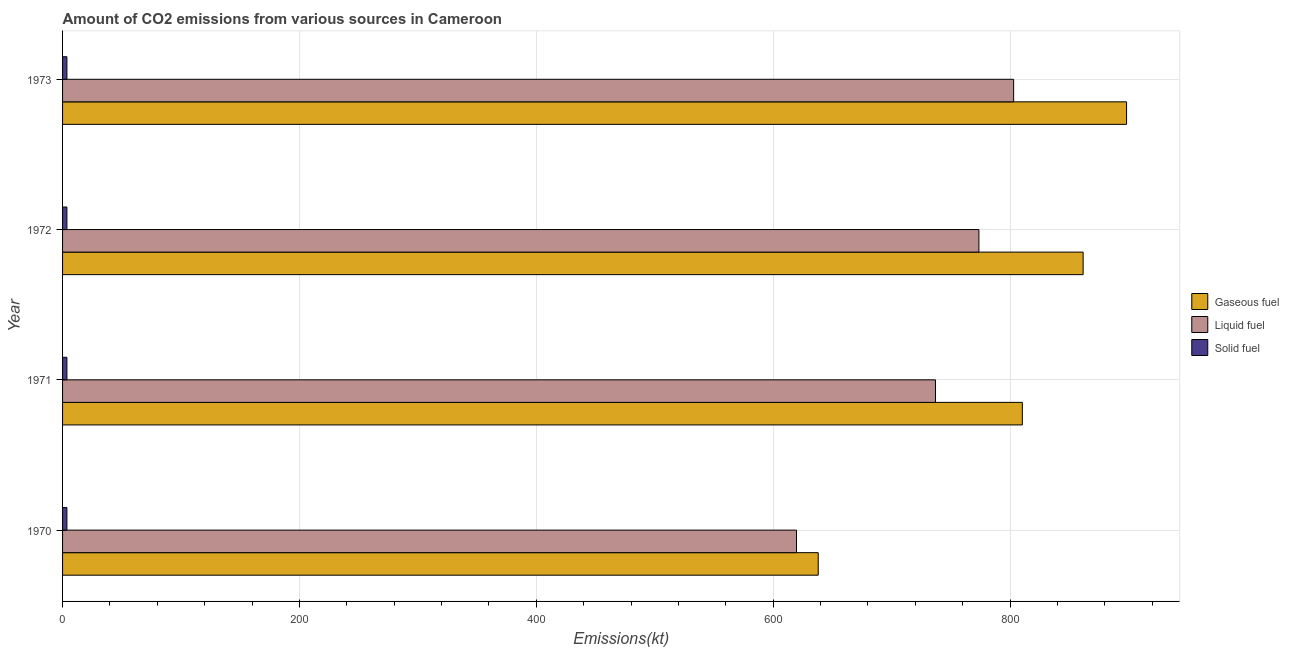How many groups of bars are there?
Give a very brief answer. 4. How many bars are there on the 1st tick from the top?
Your response must be concise. 3. What is the amount of co2 emissions from solid fuel in 1973?
Ensure brevity in your answer.  3.67. Across all years, what is the maximum amount of co2 emissions from gaseous fuel?
Give a very brief answer. 898.41. Across all years, what is the minimum amount of co2 emissions from liquid fuel?
Make the answer very short. 619.72. In which year was the amount of co2 emissions from gaseous fuel maximum?
Offer a terse response. 1973. What is the total amount of co2 emissions from gaseous fuel in the graph?
Make the answer very short. 3208.62. What is the difference between the amount of co2 emissions from gaseous fuel in 1970 and that in 1973?
Give a very brief answer. -260.36. What is the difference between the amount of co2 emissions from gaseous fuel in 1973 and the amount of co2 emissions from solid fuel in 1971?
Make the answer very short. 894.75. What is the average amount of co2 emissions from solid fuel per year?
Your answer should be very brief. 3.67. In the year 1972, what is the difference between the amount of co2 emissions from liquid fuel and amount of co2 emissions from gaseous fuel?
Offer a terse response. -88.01. In how many years, is the amount of co2 emissions from gaseous fuel greater than 120 kt?
Keep it short and to the point. 4. Is the amount of co2 emissions from liquid fuel in 1971 less than that in 1972?
Provide a short and direct response. Yes. What is the difference between the highest and the second highest amount of co2 emissions from gaseous fuel?
Your response must be concise. 36.67. What is the difference between the highest and the lowest amount of co2 emissions from solid fuel?
Offer a very short reply. 0. What does the 1st bar from the top in 1973 represents?
Provide a succinct answer. Solid fuel. What does the 3rd bar from the bottom in 1970 represents?
Keep it short and to the point. Solid fuel. How many bars are there?
Your answer should be very brief. 12. What is the difference between two consecutive major ticks on the X-axis?
Make the answer very short. 200. Does the graph contain grids?
Give a very brief answer. Yes. Where does the legend appear in the graph?
Your response must be concise. Center right. How are the legend labels stacked?
Provide a short and direct response. Vertical. What is the title of the graph?
Offer a very short reply. Amount of CO2 emissions from various sources in Cameroon. Does "Infant(female)" appear as one of the legend labels in the graph?
Keep it short and to the point. No. What is the label or title of the X-axis?
Your answer should be very brief. Emissions(kt). What is the Emissions(kt) of Gaseous fuel in 1970?
Make the answer very short. 638.06. What is the Emissions(kt) of Liquid fuel in 1970?
Keep it short and to the point. 619.72. What is the Emissions(kt) in Solid fuel in 1970?
Your answer should be very brief. 3.67. What is the Emissions(kt) of Gaseous fuel in 1971?
Keep it short and to the point. 810.41. What is the Emissions(kt) of Liquid fuel in 1971?
Your answer should be very brief. 737.07. What is the Emissions(kt) in Solid fuel in 1971?
Offer a very short reply. 3.67. What is the Emissions(kt) of Gaseous fuel in 1972?
Ensure brevity in your answer.  861.75. What is the Emissions(kt) of Liquid fuel in 1972?
Ensure brevity in your answer.  773.74. What is the Emissions(kt) in Solid fuel in 1972?
Ensure brevity in your answer.  3.67. What is the Emissions(kt) of Gaseous fuel in 1973?
Keep it short and to the point. 898.41. What is the Emissions(kt) of Liquid fuel in 1973?
Give a very brief answer. 803.07. What is the Emissions(kt) in Solid fuel in 1973?
Give a very brief answer. 3.67. Across all years, what is the maximum Emissions(kt) of Gaseous fuel?
Give a very brief answer. 898.41. Across all years, what is the maximum Emissions(kt) of Liquid fuel?
Make the answer very short. 803.07. Across all years, what is the maximum Emissions(kt) in Solid fuel?
Keep it short and to the point. 3.67. Across all years, what is the minimum Emissions(kt) in Gaseous fuel?
Your response must be concise. 638.06. Across all years, what is the minimum Emissions(kt) of Liquid fuel?
Offer a terse response. 619.72. Across all years, what is the minimum Emissions(kt) of Solid fuel?
Provide a short and direct response. 3.67. What is the total Emissions(kt) in Gaseous fuel in the graph?
Keep it short and to the point. 3208.62. What is the total Emissions(kt) in Liquid fuel in the graph?
Give a very brief answer. 2933.6. What is the total Emissions(kt) in Solid fuel in the graph?
Provide a short and direct response. 14.67. What is the difference between the Emissions(kt) of Gaseous fuel in 1970 and that in 1971?
Offer a very short reply. -172.35. What is the difference between the Emissions(kt) of Liquid fuel in 1970 and that in 1971?
Your answer should be very brief. -117.34. What is the difference between the Emissions(kt) in Gaseous fuel in 1970 and that in 1972?
Provide a succinct answer. -223.69. What is the difference between the Emissions(kt) in Liquid fuel in 1970 and that in 1972?
Make the answer very short. -154.01. What is the difference between the Emissions(kt) of Solid fuel in 1970 and that in 1972?
Keep it short and to the point. 0. What is the difference between the Emissions(kt) of Gaseous fuel in 1970 and that in 1973?
Offer a terse response. -260.36. What is the difference between the Emissions(kt) in Liquid fuel in 1970 and that in 1973?
Give a very brief answer. -183.35. What is the difference between the Emissions(kt) in Solid fuel in 1970 and that in 1973?
Provide a short and direct response. 0. What is the difference between the Emissions(kt) in Gaseous fuel in 1971 and that in 1972?
Your response must be concise. -51.34. What is the difference between the Emissions(kt) in Liquid fuel in 1971 and that in 1972?
Offer a very short reply. -36.67. What is the difference between the Emissions(kt) in Solid fuel in 1971 and that in 1972?
Your answer should be compact. 0. What is the difference between the Emissions(kt) in Gaseous fuel in 1971 and that in 1973?
Offer a very short reply. -88.01. What is the difference between the Emissions(kt) of Liquid fuel in 1971 and that in 1973?
Give a very brief answer. -66.01. What is the difference between the Emissions(kt) in Gaseous fuel in 1972 and that in 1973?
Make the answer very short. -36.67. What is the difference between the Emissions(kt) of Liquid fuel in 1972 and that in 1973?
Your response must be concise. -29.34. What is the difference between the Emissions(kt) in Gaseous fuel in 1970 and the Emissions(kt) in Liquid fuel in 1971?
Provide a short and direct response. -99.01. What is the difference between the Emissions(kt) in Gaseous fuel in 1970 and the Emissions(kt) in Solid fuel in 1971?
Provide a succinct answer. 634.39. What is the difference between the Emissions(kt) of Liquid fuel in 1970 and the Emissions(kt) of Solid fuel in 1971?
Offer a terse response. 616.06. What is the difference between the Emissions(kt) of Gaseous fuel in 1970 and the Emissions(kt) of Liquid fuel in 1972?
Give a very brief answer. -135.68. What is the difference between the Emissions(kt) in Gaseous fuel in 1970 and the Emissions(kt) in Solid fuel in 1972?
Provide a short and direct response. 634.39. What is the difference between the Emissions(kt) of Liquid fuel in 1970 and the Emissions(kt) of Solid fuel in 1972?
Provide a short and direct response. 616.06. What is the difference between the Emissions(kt) in Gaseous fuel in 1970 and the Emissions(kt) in Liquid fuel in 1973?
Your answer should be compact. -165.01. What is the difference between the Emissions(kt) of Gaseous fuel in 1970 and the Emissions(kt) of Solid fuel in 1973?
Your response must be concise. 634.39. What is the difference between the Emissions(kt) in Liquid fuel in 1970 and the Emissions(kt) in Solid fuel in 1973?
Offer a very short reply. 616.06. What is the difference between the Emissions(kt) of Gaseous fuel in 1971 and the Emissions(kt) of Liquid fuel in 1972?
Provide a succinct answer. 36.67. What is the difference between the Emissions(kt) of Gaseous fuel in 1971 and the Emissions(kt) of Solid fuel in 1972?
Provide a short and direct response. 806.74. What is the difference between the Emissions(kt) in Liquid fuel in 1971 and the Emissions(kt) in Solid fuel in 1972?
Ensure brevity in your answer.  733.4. What is the difference between the Emissions(kt) in Gaseous fuel in 1971 and the Emissions(kt) in Liquid fuel in 1973?
Your answer should be compact. 7.33. What is the difference between the Emissions(kt) of Gaseous fuel in 1971 and the Emissions(kt) of Solid fuel in 1973?
Ensure brevity in your answer.  806.74. What is the difference between the Emissions(kt) of Liquid fuel in 1971 and the Emissions(kt) of Solid fuel in 1973?
Provide a succinct answer. 733.4. What is the difference between the Emissions(kt) of Gaseous fuel in 1972 and the Emissions(kt) of Liquid fuel in 1973?
Your answer should be compact. 58.67. What is the difference between the Emissions(kt) of Gaseous fuel in 1972 and the Emissions(kt) of Solid fuel in 1973?
Your answer should be compact. 858.08. What is the difference between the Emissions(kt) of Liquid fuel in 1972 and the Emissions(kt) of Solid fuel in 1973?
Keep it short and to the point. 770.07. What is the average Emissions(kt) of Gaseous fuel per year?
Provide a succinct answer. 802.16. What is the average Emissions(kt) in Liquid fuel per year?
Provide a succinct answer. 733.4. What is the average Emissions(kt) in Solid fuel per year?
Offer a terse response. 3.67. In the year 1970, what is the difference between the Emissions(kt) in Gaseous fuel and Emissions(kt) in Liquid fuel?
Make the answer very short. 18.34. In the year 1970, what is the difference between the Emissions(kt) of Gaseous fuel and Emissions(kt) of Solid fuel?
Offer a terse response. 634.39. In the year 1970, what is the difference between the Emissions(kt) in Liquid fuel and Emissions(kt) in Solid fuel?
Provide a succinct answer. 616.06. In the year 1971, what is the difference between the Emissions(kt) of Gaseous fuel and Emissions(kt) of Liquid fuel?
Your answer should be very brief. 73.34. In the year 1971, what is the difference between the Emissions(kt) of Gaseous fuel and Emissions(kt) of Solid fuel?
Your answer should be very brief. 806.74. In the year 1971, what is the difference between the Emissions(kt) in Liquid fuel and Emissions(kt) in Solid fuel?
Keep it short and to the point. 733.4. In the year 1972, what is the difference between the Emissions(kt) of Gaseous fuel and Emissions(kt) of Liquid fuel?
Ensure brevity in your answer.  88.01. In the year 1972, what is the difference between the Emissions(kt) in Gaseous fuel and Emissions(kt) in Solid fuel?
Your answer should be compact. 858.08. In the year 1972, what is the difference between the Emissions(kt) in Liquid fuel and Emissions(kt) in Solid fuel?
Provide a succinct answer. 770.07. In the year 1973, what is the difference between the Emissions(kt) in Gaseous fuel and Emissions(kt) in Liquid fuel?
Your answer should be compact. 95.34. In the year 1973, what is the difference between the Emissions(kt) of Gaseous fuel and Emissions(kt) of Solid fuel?
Ensure brevity in your answer.  894.75. In the year 1973, what is the difference between the Emissions(kt) in Liquid fuel and Emissions(kt) in Solid fuel?
Give a very brief answer. 799.41. What is the ratio of the Emissions(kt) of Gaseous fuel in 1970 to that in 1971?
Provide a short and direct response. 0.79. What is the ratio of the Emissions(kt) in Liquid fuel in 1970 to that in 1971?
Ensure brevity in your answer.  0.84. What is the ratio of the Emissions(kt) of Gaseous fuel in 1970 to that in 1972?
Your response must be concise. 0.74. What is the ratio of the Emissions(kt) of Liquid fuel in 1970 to that in 1972?
Provide a short and direct response. 0.8. What is the ratio of the Emissions(kt) in Gaseous fuel in 1970 to that in 1973?
Provide a short and direct response. 0.71. What is the ratio of the Emissions(kt) of Liquid fuel in 1970 to that in 1973?
Make the answer very short. 0.77. What is the ratio of the Emissions(kt) of Gaseous fuel in 1971 to that in 1972?
Your answer should be very brief. 0.94. What is the ratio of the Emissions(kt) in Liquid fuel in 1971 to that in 1972?
Keep it short and to the point. 0.95. What is the ratio of the Emissions(kt) in Gaseous fuel in 1971 to that in 1973?
Give a very brief answer. 0.9. What is the ratio of the Emissions(kt) of Liquid fuel in 1971 to that in 1973?
Provide a succinct answer. 0.92. What is the ratio of the Emissions(kt) in Gaseous fuel in 1972 to that in 1973?
Give a very brief answer. 0.96. What is the ratio of the Emissions(kt) in Liquid fuel in 1972 to that in 1973?
Provide a succinct answer. 0.96. What is the ratio of the Emissions(kt) of Solid fuel in 1972 to that in 1973?
Make the answer very short. 1. What is the difference between the highest and the second highest Emissions(kt) in Gaseous fuel?
Provide a succinct answer. 36.67. What is the difference between the highest and the second highest Emissions(kt) in Liquid fuel?
Make the answer very short. 29.34. What is the difference between the highest and the lowest Emissions(kt) in Gaseous fuel?
Ensure brevity in your answer.  260.36. What is the difference between the highest and the lowest Emissions(kt) of Liquid fuel?
Make the answer very short. 183.35. 